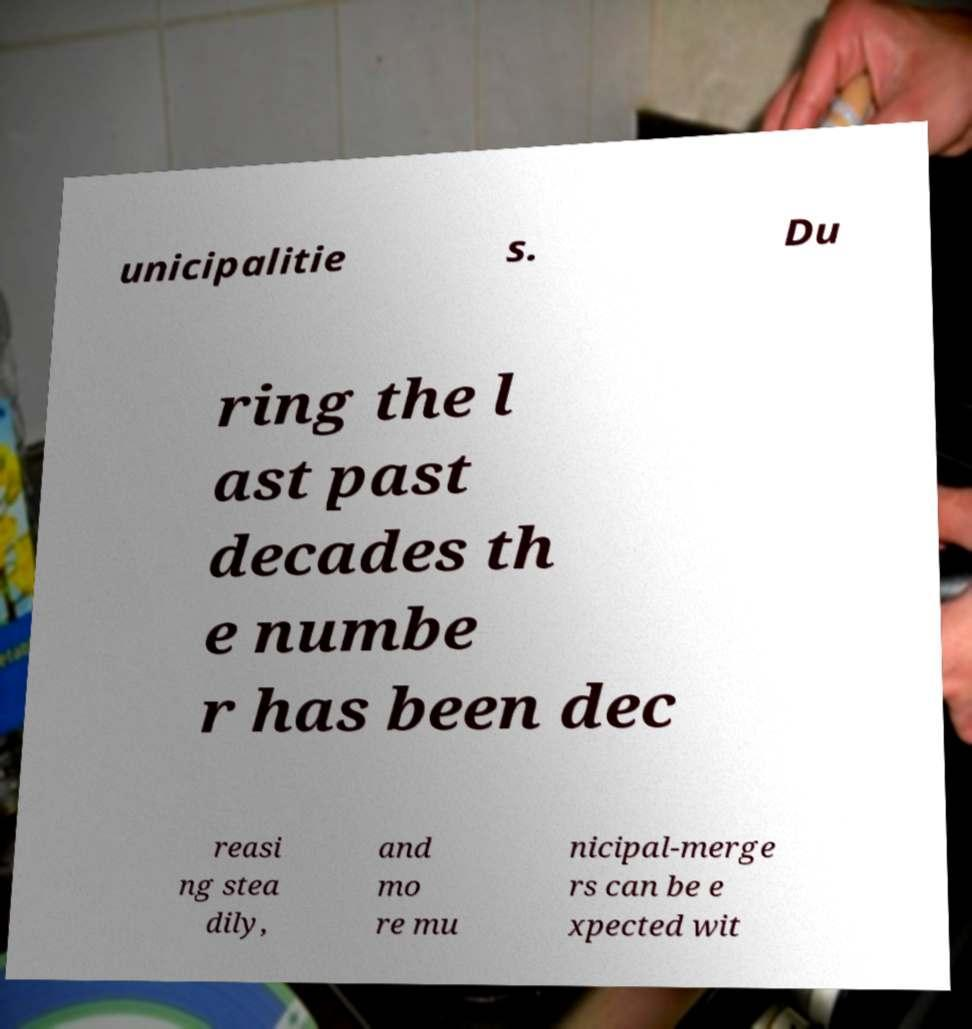Please identify and transcribe the text found in this image. unicipalitie s. Du ring the l ast past decades th e numbe r has been dec reasi ng stea dily, and mo re mu nicipal-merge rs can be e xpected wit 